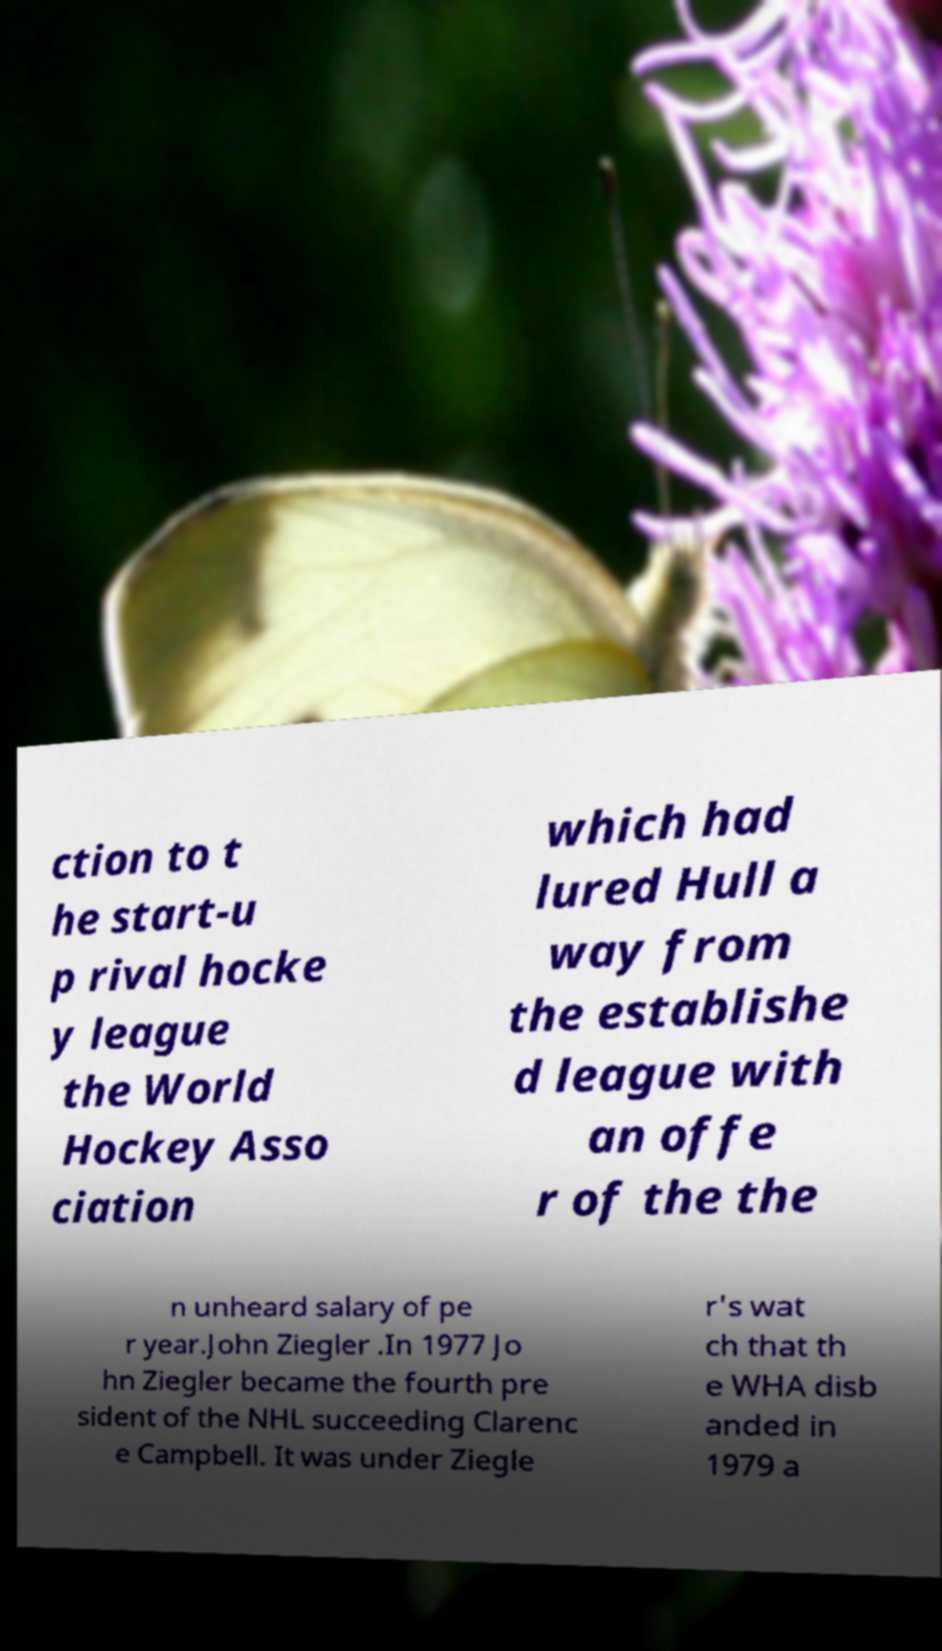Please read and relay the text visible in this image. What does it say? ction to t he start-u p rival hocke y league the World Hockey Asso ciation which had lured Hull a way from the establishe d league with an offe r of the the n unheard salary of pe r year.John Ziegler .In 1977 Jo hn Ziegler became the fourth pre sident of the NHL succeeding Clarenc e Campbell. It was under Ziegle r's wat ch that th e WHA disb anded in 1979 a 